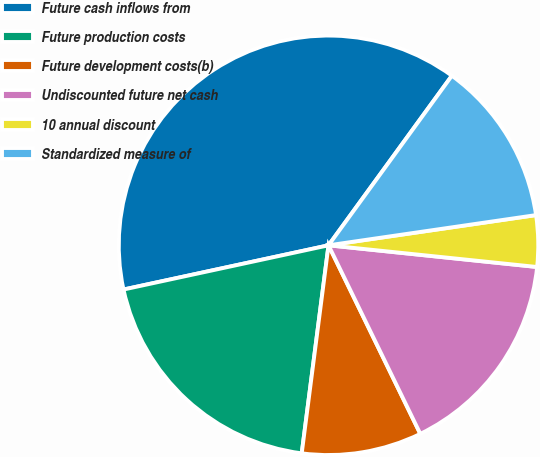<chart> <loc_0><loc_0><loc_500><loc_500><pie_chart><fcel>Future cash inflows from<fcel>Future production costs<fcel>Future development costs(b)<fcel>Undiscounted future net cash<fcel>10 annual discount<fcel>Standardized measure of<nl><fcel>38.39%<fcel>19.58%<fcel>9.25%<fcel>16.14%<fcel>3.95%<fcel>12.69%<nl></chart> 